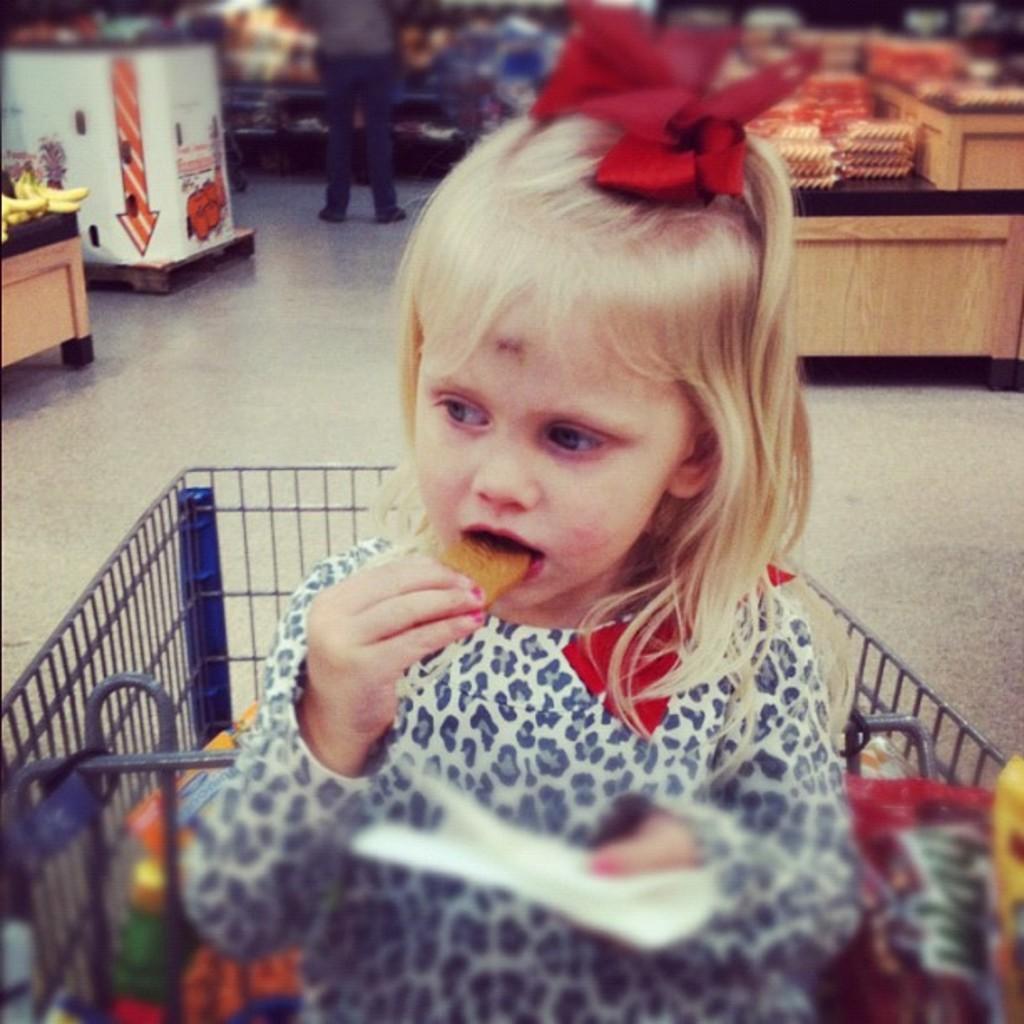Please provide a concise description of this image. In this picture we can see a kid holding an object in one hand and eating a food item with the other hand. There are some food items, a person standing and other objects. Background is blurry. 